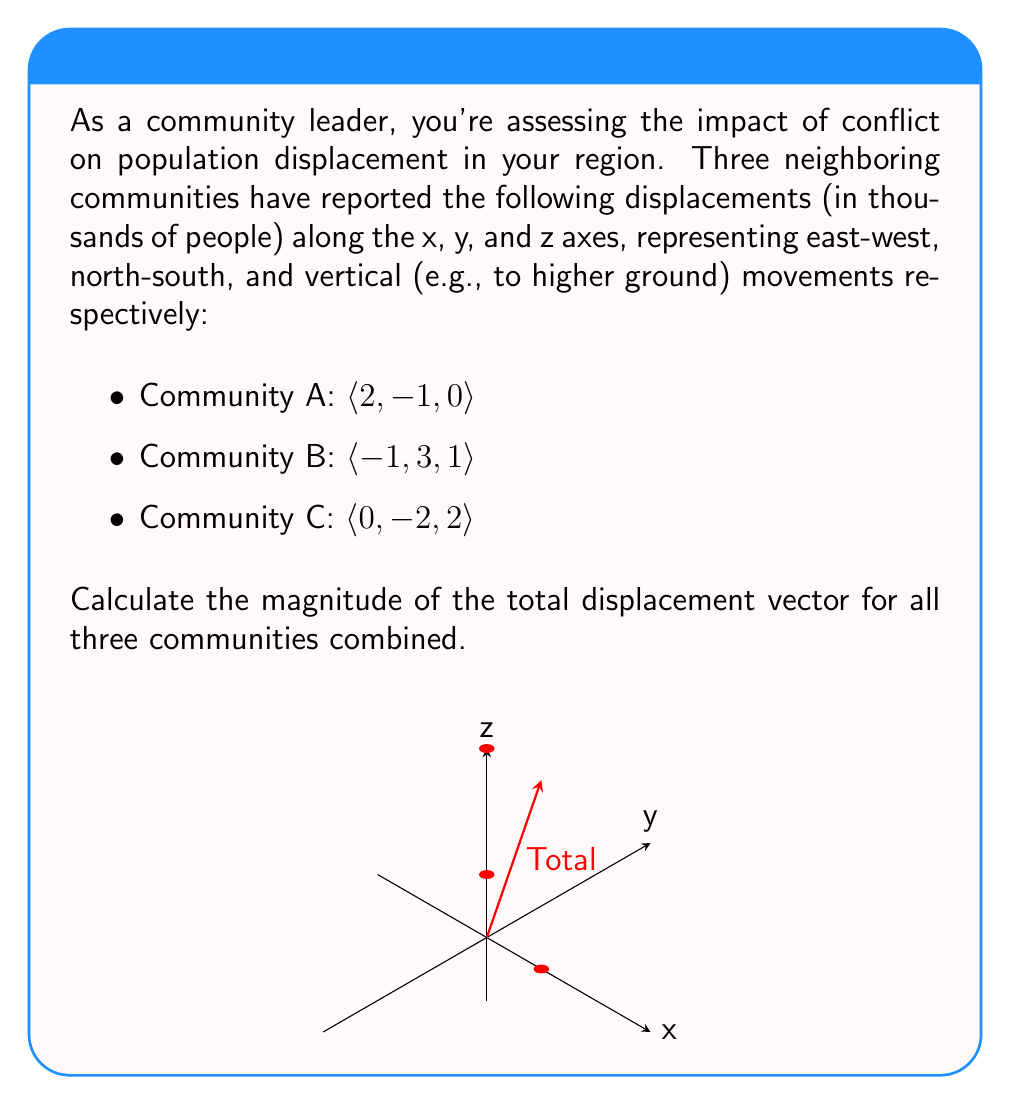Can you solve this math problem? Let's approach this step-by-step:

1) First, we need to sum the displacement vectors from all three communities:

   Total displacement = A + B + C
   = $\langle 2, -1, 0 \rangle + \langle -1, 3, 1 \rangle + \langle 0, -2, 2 \rangle$

2) Add the components:
   = $\langle (2-1+0), (-1+3-2), (0+1+2) \rangle$
   = $\langle 1, 0, 3 \rangle$

3) Now we have the total displacement vector. To find its magnitude, we use the formula:

   $$\text{Magnitude} = \sqrt{x^2 + y^2 + z^2}$$

   Where x, y, and z are the components of the vector.

4) Substituting our values:

   $$\text{Magnitude} = \sqrt{1^2 + 0^2 + 3^2}$$

5) Simplify:
   $$\text{Magnitude} = \sqrt{1 + 0 + 9} = \sqrt{10}$$

Therefore, the magnitude of the total displacement vector is $\sqrt{10}$ thousand people.
Answer: $\sqrt{10}$ thousand people 